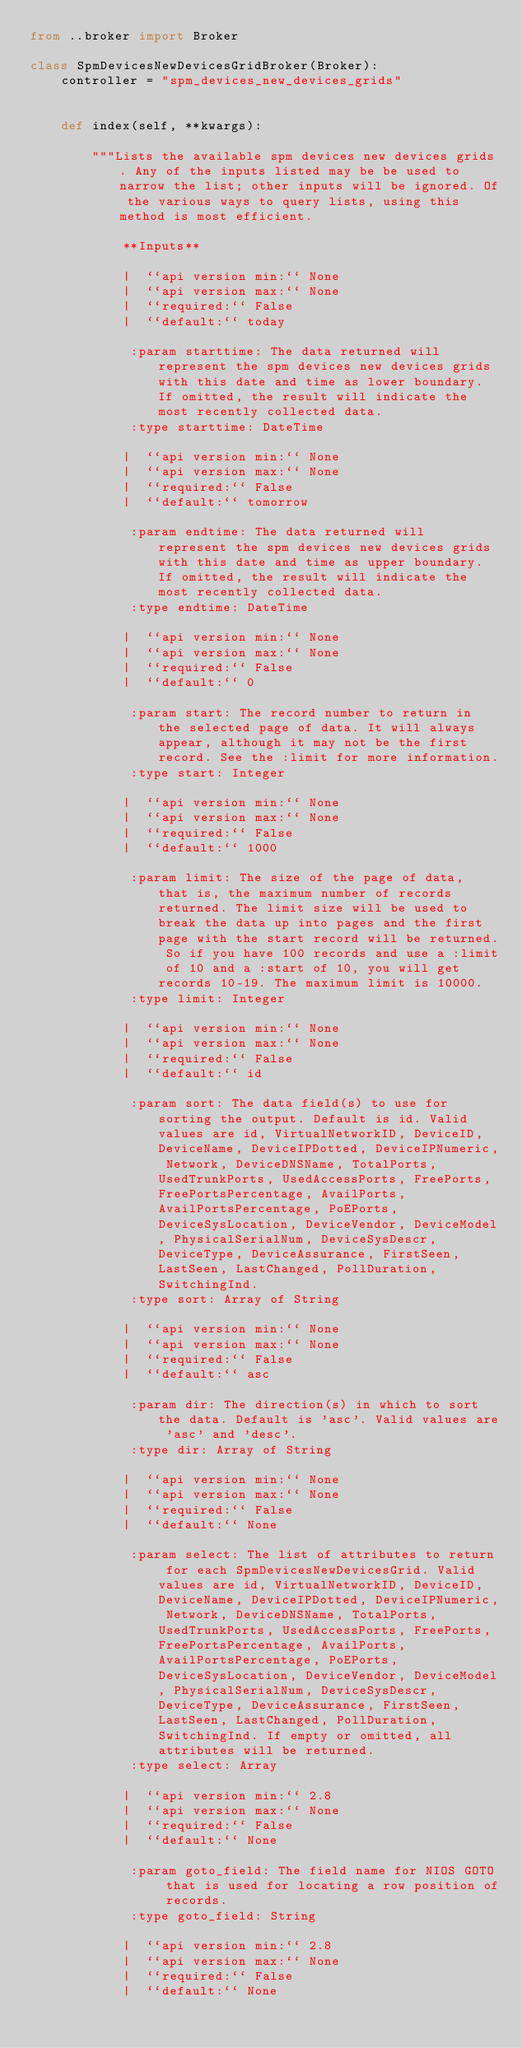Convert code to text. <code><loc_0><loc_0><loc_500><loc_500><_Python_>from ..broker import Broker

class SpmDevicesNewDevicesGridBroker(Broker):
    controller = "spm_devices_new_devices_grids"
    
    
    def index(self, **kwargs):
    
        """Lists the available spm devices new devices grids. Any of the inputs listed may be be used to narrow the list; other inputs will be ignored. Of the various ways to query lists, using this method is most efficient.

            **Inputs**

            |  ``api version min:`` None
            |  ``api version max:`` None
            |  ``required:`` False
            |  ``default:`` today

             :param starttime: The data returned will represent the spm devices new devices grids with this date and time as lower boundary. If omitted, the result will indicate the most recently collected data.
             :type starttime: DateTime

            |  ``api version min:`` None
            |  ``api version max:`` None
            |  ``required:`` False
            |  ``default:`` tomorrow

             :param endtime: The data returned will represent the spm devices new devices grids with this date and time as upper boundary. If omitted, the result will indicate the most recently collected data.
             :type endtime: DateTime

            |  ``api version min:`` None
            |  ``api version max:`` None
            |  ``required:`` False
            |  ``default:`` 0

             :param start: The record number to return in the selected page of data. It will always appear, although it may not be the first record. See the :limit for more information.
             :type start: Integer

            |  ``api version min:`` None
            |  ``api version max:`` None
            |  ``required:`` False
            |  ``default:`` 1000

             :param limit: The size of the page of data, that is, the maximum number of records returned. The limit size will be used to break the data up into pages and the first page with the start record will be returned. So if you have 100 records and use a :limit of 10 and a :start of 10, you will get records 10-19. The maximum limit is 10000.
             :type limit: Integer

            |  ``api version min:`` None
            |  ``api version max:`` None
            |  ``required:`` False
            |  ``default:`` id

             :param sort: The data field(s) to use for sorting the output. Default is id. Valid values are id, VirtualNetworkID, DeviceID, DeviceName, DeviceIPDotted, DeviceIPNumeric, Network, DeviceDNSName, TotalPorts, UsedTrunkPorts, UsedAccessPorts, FreePorts, FreePortsPercentage, AvailPorts, AvailPortsPercentage, PoEPorts, DeviceSysLocation, DeviceVendor, DeviceModel, PhysicalSerialNum, DeviceSysDescr, DeviceType, DeviceAssurance, FirstSeen, LastSeen, LastChanged, PollDuration, SwitchingInd.
             :type sort: Array of String

            |  ``api version min:`` None
            |  ``api version max:`` None
            |  ``required:`` False
            |  ``default:`` asc

             :param dir: The direction(s) in which to sort the data. Default is 'asc'. Valid values are 'asc' and 'desc'.
             :type dir: Array of String

            |  ``api version min:`` None
            |  ``api version max:`` None
            |  ``required:`` False
            |  ``default:`` None

             :param select: The list of attributes to return for each SpmDevicesNewDevicesGrid. Valid values are id, VirtualNetworkID, DeviceID, DeviceName, DeviceIPDotted, DeviceIPNumeric, Network, DeviceDNSName, TotalPorts, UsedTrunkPorts, UsedAccessPorts, FreePorts, FreePortsPercentage, AvailPorts, AvailPortsPercentage, PoEPorts, DeviceSysLocation, DeviceVendor, DeviceModel, PhysicalSerialNum, DeviceSysDescr, DeviceType, DeviceAssurance, FirstSeen, LastSeen, LastChanged, PollDuration, SwitchingInd. If empty or omitted, all attributes will be returned.
             :type select: Array

            |  ``api version min:`` 2.8
            |  ``api version max:`` None
            |  ``required:`` False
            |  ``default:`` None

             :param goto_field: The field name for NIOS GOTO that is used for locating a row position of records.
             :type goto_field: String

            |  ``api version min:`` 2.8
            |  ``api version max:`` None
            |  ``required:`` False
            |  ``default:`` None
</code> 